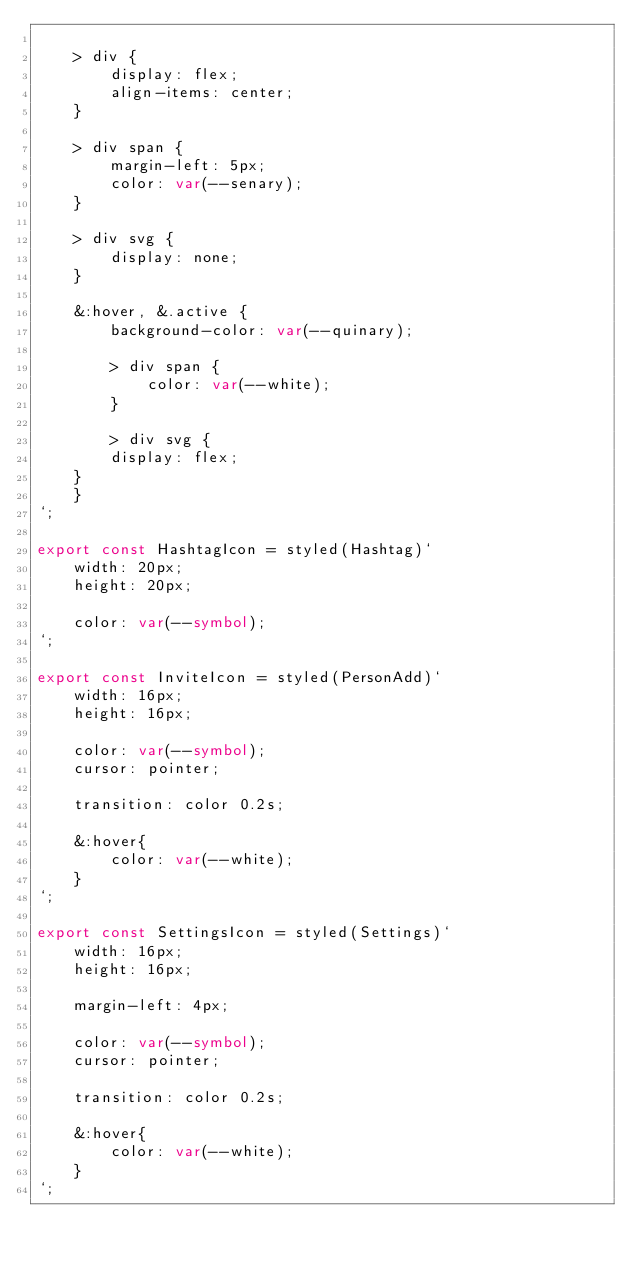<code> <loc_0><loc_0><loc_500><loc_500><_TypeScript_>
    > div {
        display: flex;
        align-items: center;
    }

    > div span {
        margin-left: 5px;
        color: var(--senary);
    }

    > div svg {
        display: none;
    }

    &:hover, &.active {
        background-color: var(--quinary);

        > div span {
            color: var(--white);
        }

        > div svg {
        display: flex;
    }
    }
`;

export const HashtagIcon = styled(Hashtag)`
    width: 20px;
    height: 20px;

    color: var(--symbol);
`;

export const InviteIcon = styled(PersonAdd)`
    width: 16px;
    height: 16px;

    color: var(--symbol);
    cursor: pointer;

    transition: color 0.2s;

    &:hover{
        color: var(--white);
    }
`;

export const SettingsIcon = styled(Settings)`
    width: 16px;
    height: 16px;

    margin-left: 4px;

    color: var(--symbol);
    cursor: pointer;

    transition: color 0.2s;

    &:hover{
        color: var(--white);
    }
`;
</code> 